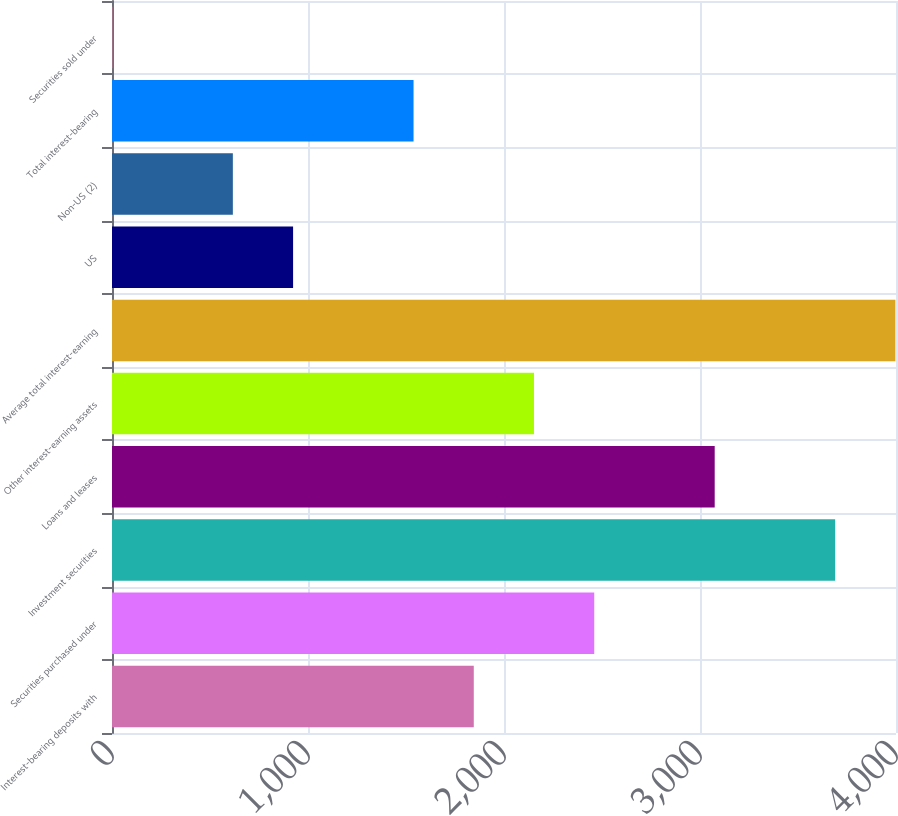Convert chart to OTSL. <chart><loc_0><loc_0><loc_500><loc_500><bar_chart><fcel>Interest-bearing deposits with<fcel>Securities purchased under<fcel>Investment securities<fcel>Loans and leases<fcel>Other interest-earning assets<fcel>Average total interest-earning<fcel>US<fcel>Non-US (2)<fcel>Total interest-bearing<fcel>Securities sold under<nl><fcel>1845.8<fcel>2460.4<fcel>3689.6<fcel>3075<fcel>2153.1<fcel>3996.9<fcel>923.9<fcel>616.6<fcel>1538.5<fcel>2<nl></chart> 